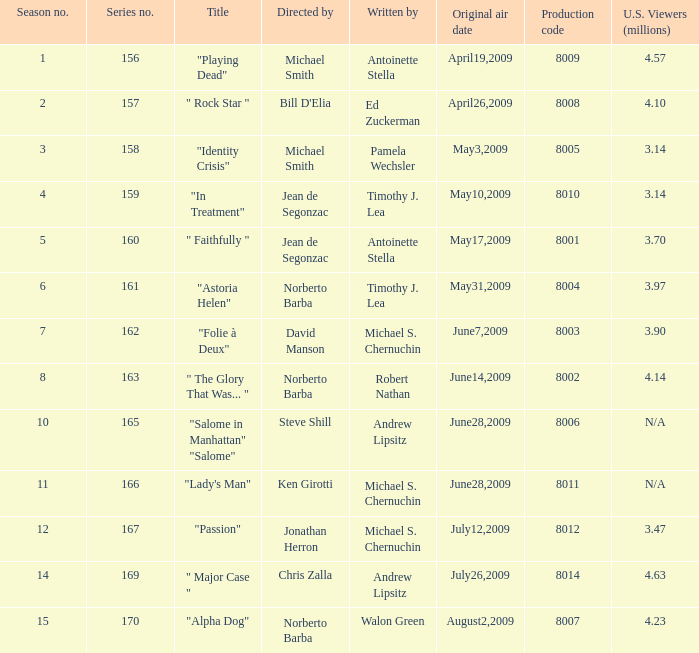What is the name of the episode whose writer is timothy j. lea and the director is norberto barba? "Astoria Helen". 